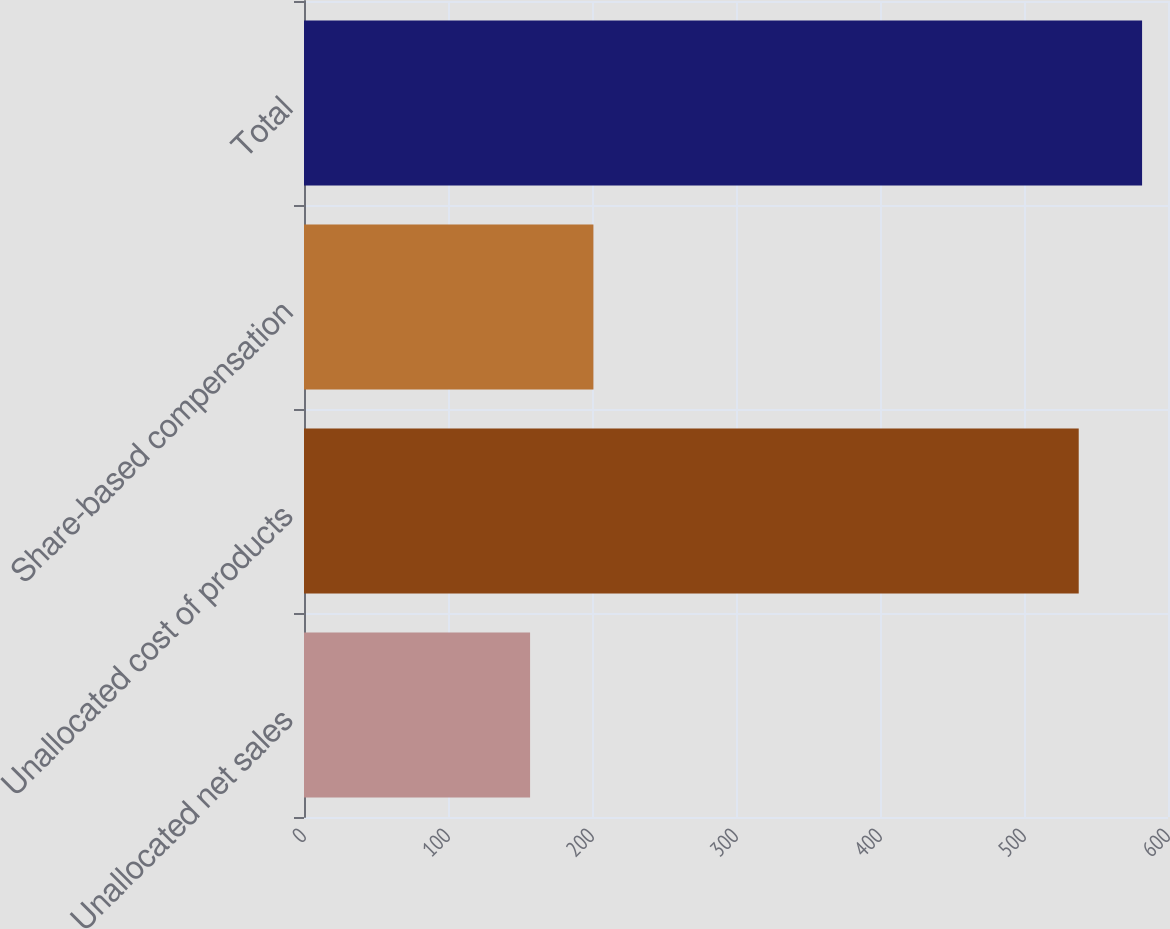Convert chart. <chart><loc_0><loc_0><loc_500><loc_500><bar_chart><fcel>Unallocated net sales<fcel>Unallocated cost of products<fcel>Share-based compensation<fcel>Total<nl><fcel>157<fcel>538<fcel>201<fcel>582<nl></chart> 